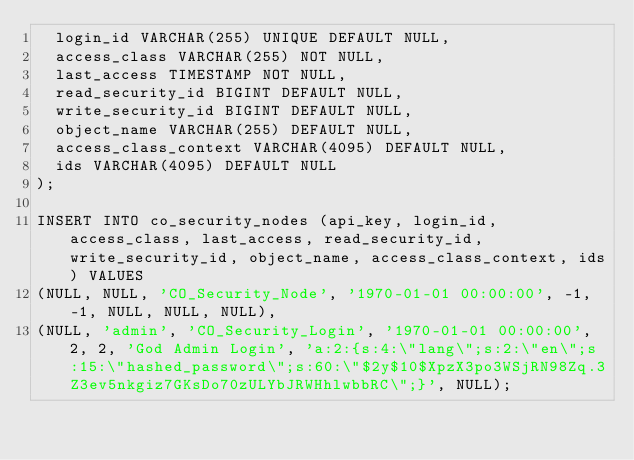<code> <loc_0><loc_0><loc_500><loc_500><_SQL_>  login_id VARCHAR(255) UNIQUE DEFAULT NULL,
  access_class VARCHAR(255) NOT NULL,
  last_access TIMESTAMP NOT NULL,
  read_security_id BIGINT DEFAULT NULL,
  write_security_id BIGINT DEFAULT NULL,
  object_name VARCHAR(255) DEFAULT NULL,
  access_class_context VARCHAR(4095) DEFAULT NULL,
  ids VARCHAR(4095) DEFAULT NULL
);

INSERT INTO co_security_nodes (api_key, login_id, access_class, last_access, read_security_id, write_security_id, object_name, access_class_context, ids) VALUES
(NULL, NULL, 'CO_Security_Node', '1970-01-01 00:00:00', -1, -1, NULL, NULL, NULL),
(NULL, 'admin', 'CO_Security_Login', '1970-01-01 00:00:00', 2, 2, 'God Admin Login', 'a:2:{s:4:\"lang\";s:2:\"en\";s:15:\"hashed_password\";s:60:\"$2y$10$XpzX3po3WSjRN98Zq.3Z3ev5nkgiz7GKsDo70zULYbJRWHhlwbbRC\";}', NULL);
</code> 